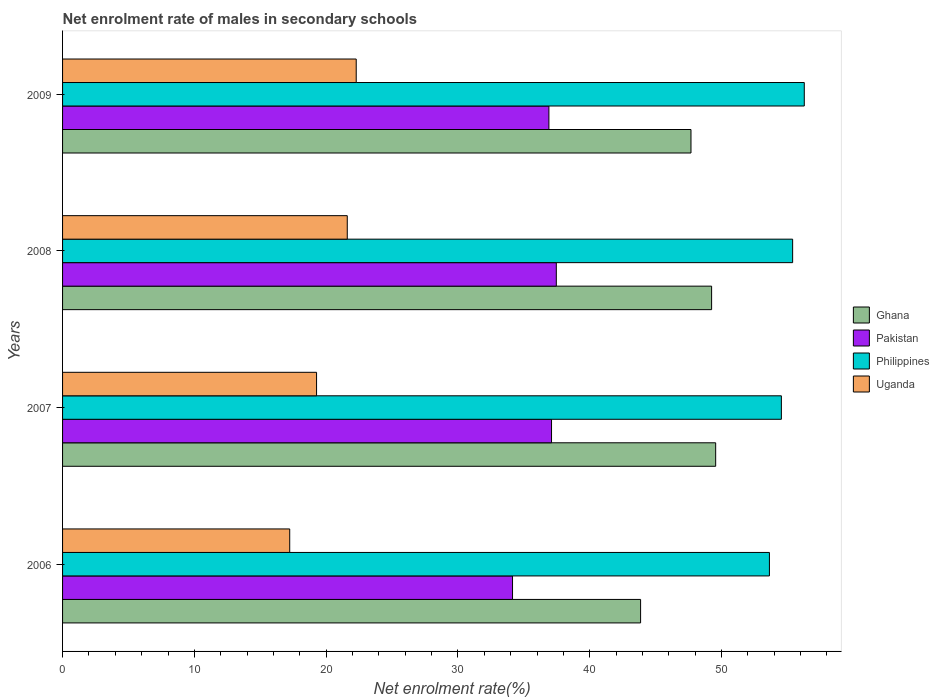How many different coloured bars are there?
Offer a very short reply. 4. Are the number of bars per tick equal to the number of legend labels?
Offer a terse response. Yes. In how many cases, is the number of bars for a given year not equal to the number of legend labels?
Ensure brevity in your answer.  0. What is the net enrolment rate of males in secondary schools in Ghana in 2006?
Your answer should be very brief. 43.86. Across all years, what is the maximum net enrolment rate of males in secondary schools in Philippines?
Your answer should be compact. 56.28. Across all years, what is the minimum net enrolment rate of males in secondary schools in Philippines?
Keep it short and to the point. 53.64. In which year was the net enrolment rate of males in secondary schools in Philippines maximum?
Keep it short and to the point. 2009. What is the total net enrolment rate of males in secondary schools in Ghana in the graph?
Your response must be concise. 190.35. What is the difference between the net enrolment rate of males in secondary schools in Philippines in 2008 and that in 2009?
Your response must be concise. -0.88. What is the difference between the net enrolment rate of males in secondary schools in Philippines in 2009 and the net enrolment rate of males in secondary schools in Ghana in 2008?
Offer a very short reply. 7.03. What is the average net enrolment rate of males in secondary schools in Ghana per year?
Your answer should be compact. 47.59. In the year 2008, what is the difference between the net enrolment rate of males in secondary schools in Ghana and net enrolment rate of males in secondary schools in Uganda?
Your response must be concise. 27.65. In how many years, is the net enrolment rate of males in secondary schools in Uganda greater than 38 %?
Provide a succinct answer. 0. What is the ratio of the net enrolment rate of males in secondary schools in Uganda in 2007 to that in 2009?
Offer a very short reply. 0.86. Is the difference between the net enrolment rate of males in secondary schools in Ghana in 2008 and 2009 greater than the difference between the net enrolment rate of males in secondary schools in Uganda in 2008 and 2009?
Keep it short and to the point. Yes. What is the difference between the highest and the second highest net enrolment rate of males in secondary schools in Uganda?
Provide a short and direct response. 0.68. What is the difference between the highest and the lowest net enrolment rate of males in secondary schools in Ghana?
Give a very brief answer. 5.7. Is it the case that in every year, the sum of the net enrolment rate of males in secondary schools in Ghana and net enrolment rate of males in secondary schools in Uganda is greater than the sum of net enrolment rate of males in secondary schools in Philippines and net enrolment rate of males in secondary schools in Pakistan?
Keep it short and to the point. Yes. What does the 1st bar from the top in 2009 represents?
Your answer should be compact. Uganda. Is it the case that in every year, the sum of the net enrolment rate of males in secondary schools in Pakistan and net enrolment rate of males in secondary schools in Philippines is greater than the net enrolment rate of males in secondary schools in Ghana?
Give a very brief answer. Yes. How many bars are there?
Ensure brevity in your answer.  16. Are all the bars in the graph horizontal?
Keep it short and to the point. Yes. How many years are there in the graph?
Keep it short and to the point. 4. Are the values on the major ticks of X-axis written in scientific E-notation?
Your answer should be very brief. No. Does the graph contain grids?
Make the answer very short. No. Where does the legend appear in the graph?
Offer a terse response. Center right. How are the legend labels stacked?
Offer a very short reply. Vertical. What is the title of the graph?
Give a very brief answer. Net enrolment rate of males in secondary schools. Does "Ecuador" appear as one of the legend labels in the graph?
Keep it short and to the point. No. What is the label or title of the X-axis?
Offer a terse response. Net enrolment rate(%). What is the label or title of the Y-axis?
Offer a very short reply. Years. What is the Net enrolment rate(%) in Ghana in 2006?
Make the answer very short. 43.86. What is the Net enrolment rate(%) in Pakistan in 2006?
Provide a succinct answer. 34.14. What is the Net enrolment rate(%) of Philippines in 2006?
Your answer should be compact. 53.64. What is the Net enrolment rate(%) in Uganda in 2006?
Make the answer very short. 17.24. What is the Net enrolment rate(%) of Ghana in 2007?
Give a very brief answer. 49.56. What is the Net enrolment rate(%) in Pakistan in 2007?
Your response must be concise. 37.1. What is the Net enrolment rate(%) in Philippines in 2007?
Your answer should be very brief. 54.54. What is the Net enrolment rate(%) in Uganda in 2007?
Your answer should be very brief. 19.27. What is the Net enrolment rate(%) in Ghana in 2008?
Make the answer very short. 49.25. What is the Net enrolment rate(%) in Pakistan in 2008?
Keep it short and to the point. 37.47. What is the Net enrolment rate(%) in Philippines in 2008?
Your answer should be compact. 55.4. What is the Net enrolment rate(%) in Uganda in 2008?
Ensure brevity in your answer.  21.6. What is the Net enrolment rate(%) of Ghana in 2009?
Your answer should be very brief. 47.68. What is the Net enrolment rate(%) in Pakistan in 2009?
Give a very brief answer. 36.9. What is the Net enrolment rate(%) in Philippines in 2009?
Offer a very short reply. 56.28. What is the Net enrolment rate(%) of Uganda in 2009?
Ensure brevity in your answer.  22.28. Across all years, what is the maximum Net enrolment rate(%) of Ghana?
Provide a succinct answer. 49.56. Across all years, what is the maximum Net enrolment rate(%) in Pakistan?
Keep it short and to the point. 37.47. Across all years, what is the maximum Net enrolment rate(%) in Philippines?
Provide a short and direct response. 56.28. Across all years, what is the maximum Net enrolment rate(%) of Uganda?
Offer a very short reply. 22.28. Across all years, what is the minimum Net enrolment rate(%) in Ghana?
Keep it short and to the point. 43.86. Across all years, what is the minimum Net enrolment rate(%) in Pakistan?
Your answer should be compact. 34.14. Across all years, what is the minimum Net enrolment rate(%) in Philippines?
Your response must be concise. 53.64. Across all years, what is the minimum Net enrolment rate(%) of Uganda?
Your answer should be very brief. 17.24. What is the total Net enrolment rate(%) of Ghana in the graph?
Your response must be concise. 190.35. What is the total Net enrolment rate(%) of Pakistan in the graph?
Give a very brief answer. 145.62. What is the total Net enrolment rate(%) in Philippines in the graph?
Your answer should be compact. 219.86. What is the total Net enrolment rate(%) of Uganda in the graph?
Provide a succinct answer. 80.4. What is the difference between the Net enrolment rate(%) of Ghana in 2006 and that in 2007?
Offer a very short reply. -5.7. What is the difference between the Net enrolment rate(%) in Pakistan in 2006 and that in 2007?
Make the answer very short. -2.96. What is the difference between the Net enrolment rate(%) of Philippines in 2006 and that in 2007?
Offer a terse response. -0.91. What is the difference between the Net enrolment rate(%) of Uganda in 2006 and that in 2007?
Keep it short and to the point. -2.04. What is the difference between the Net enrolment rate(%) in Ghana in 2006 and that in 2008?
Your response must be concise. -5.39. What is the difference between the Net enrolment rate(%) in Pakistan in 2006 and that in 2008?
Keep it short and to the point. -3.32. What is the difference between the Net enrolment rate(%) in Philippines in 2006 and that in 2008?
Your response must be concise. -1.76. What is the difference between the Net enrolment rate(%) in Uganda in 2006 and that in 2008?
Give a very brief answer. -4.37. What is the difference between the Net enrolment rate(%) in Ghana in 2006 and that in 2009?
Offer a very short reply. -3.82. What is the difference between the Net enrolment rate(%) of Pakistan in 2006 and that in 2009?
Make the answer very short. -2.76. What is the difference between the Net enrolment rate(%) in Philippines in 2006 and that in 2009?
Offer a terse response. -2.64. What is the difference between the Net enrolment rate(%) in Uganda in 2006 and that in 2009?
Offer a terse response. -5.05. What is the difference between the Net enrolment rate(%) in Ghana in 2007 and that in 2008?
Offer a terse response. 0.31. What is the difference between the Net enrolment rate(%) of Pakistan in 2007 and that in 2008?
Offer a very short reply. -0.36. What is the difference between the Net enrolment rate(%) in Philippines in 2007 and that in 2008?
Ensure brevity in your answer.  -0.85. What is the difference between the Net enrolment rate(%) of Uganda in 2007 and that in 2008?
Provide a short and direct response. -2.33. What is the difference between the Net enrolment rate(%) of Ghana in 2007 and that in 2009?
Offer a terse response. 1.87. What is the difference between the Net enrolment rate(%) in Pakistan in 2007 and that in 2009?
Your answer should be compact. 0.2. What is the difference between the Net enrolment rate(%) of Philippines in 2007 and that in 2009?
Offer a very short reply. -1.74. What is the difference between the Net enrolment rate(%) in Uganda in 2007 and that in 2009?
Keep it short and to the point. -3.01. What is the difference between the Net enrolment rate(%) in Ghana in 2008 and that in 2009?
Your answer should be very brief. 1.57. What is the difference between the Net enrolment rate(%) in Pakistan in 2008 and that in 2009?
Ensure brevity in your answer.  0.56. What is the difference between the Net enrolment rate(%) in Philippines in 2008 and that in 2009?
Give a very brief answer. -0.88. What is the difference between the Net enrolment rate(%) in Uganda in 2008 and that in 2009?
Ensure brevity in your answer.  -0.68. What is the difference between the Net enrolment rate(%) of Ghana in 2006 and the Net enrolment rate(%) of Pakistan in 2007?
Keep it short and to the point. 6.76. What is the difference between the Net enrolment rate(%) in Ghana in 2006 and the Net enrolment rate(%) in Philippines in 2007?
Your answer should be very brief. -10.68. What is the difference between the Net enrolment rate(%) in Ghana in 2006 and the Net enrolment rate(%) in Uganda in 2007?
Provide a short and direct response. 24.59. What is the difference between the Net enrolment rate(%) of Pakistan in 2006 and the Net enrolment rate(%) of Philippines in 2007?
Offer a terse response. -20.4. What is the difference between the Net enrolment rate(%) in Pakistan in 2006 and the Net enrolment rate(%) in Uganda in 2007?
Provide a succinct answer. 14.87. What is the difference between the Net enrolment rate(%) in Philippines in 2006 and the Net enrolment rate(%) in Uganda in 2007?
Your answer should be compact. 34.36. What is the difference between the Net enrolment rate(%) of Ghana in 2006 and the Net enrolment rate(%) of Pakistan in 2008?
Offer a terse response. 6.4. What is the difference between the Net enrolment rate(%) of Ghana in 2006 and the Net enrolment rate(%) of Philippines in 2008?
Your answer should be very brief. -11.54. What is the difference between the Net enrolment rate(%) of Ghana in 2006 and the Net enrolment rate(%) of Uganda in 2008?
Provide a short and direct response. 22.26. What is the difference between the Net enrolment rate(%) in Pakistan in 2006 and the Net enrolment rate(%) in Philippines in 2008?
Your answer should be very brief. -21.25. What is the difference between the Net enrolment rate(%) in Pakistan in 2006 and the Net enrolment rate(%) in Uganda in 2008?
Offer a very short reply. 12.54. What is the difference between the Net enrolment rate(%) in Philippines in 2006 and the Net enrolment rate(%) in Uganda in 2008?
Ensure brevity in your answer.  32.03. What is the difference between the Net enrolment rate(%) of Ghana in 2006 and the Net enrolment rate(%) of Pakistan in 2009?
Offer a terse response. 6.96. What is the difference between the Net enrolment rate(%) in Ghana in 2006 and the Net enrolment rate(%) in Philippines in 2009?
Provide a succinct answer. -12.42. What is the difference between the Net enrolment rate(%) in Ghana in 2006 and the Net enrolment rate(%) in Uganda in 2009?
Provide a succinct answer. 21.58. What is the difference between the Net enrolment rate(%) in Pakistan in 2006 and the Net enrolment rate(%) in Philippines in 2009?
Ensure brevity in your answer.  -22.14. What is the difference between the Net enrolment rate(%) of Pakistan in 2006 and the Net enrolment rate(%) of Uganda in 2009?
Provide a succinct answer. 11.86. What is the difference between the Net enrolment rate(%) in Philippines in 2006 and the Net enrolment rate(%) in Uganda in 2009?
Make the answer very short. 31.35. What is the difference between the Net enrolment rate(%) in Ghana in 2007 and the Net enrolment rate(%) in Pakistan in 2008?
Keep it short and to the point. 12.09. What is the difference between the Net enrolment rate(%) in Ghana in 2007 and the Net enrolment rate(%) in Philippines in 2008?
Make the answer very short. -5.84. What is the difference between the Net enrolment rate(%) in Ghana in 2007 and the Net enrolment rate(%) in Uganda in 2008?
Make the answer very short. 27.95. What is the difference between the Net enrolment rate(%) in Pakistan in 2007 and the Net enrolment rate(%) in Philippines in 2008?
Your answer should be very brief. -18.3. What is the difference between the Net enrolment rate(%) in Pakistan in 2007 and the Net enrolment rate(%) in Uganda in 2008?
Your answer should be compact. 15.5. What is the difference between the Net enrolment rate(%) of Philippines in 2007 and the Net enrolment rate(%) of Uganda in 2008?
Your response must be concise. 32.94. What is the difference between the Net enrolment rate(%) in Ghana in 2007 and the Net enrolment rate(%) in Pakistan in 2009?
Your answer should be very brief. 12.65. What is the difference between the Net enrolment rate(%) in Ghana in 2007 and the Net enrolment rate(%) in Philippines in 2009?
Your response must be concise. -6.72. What is the difference between the Net enrolment rate(%) in Ghana in 2007 and the Net enrolment rate(%) in Uganda in 2009?
Offer a terse response. 27.27. What is the difference between the Net enrolment rate(%) in Pakistan in 2007 and the Net enrolment rate(%) in Philippines in 2009?
Give a very brief answer. -19.18. What is the difference between the Net enrolment rate(%) in Pakistan in 2007 and the Net enrolment rate(%) in Uganda in 2009?
Make the answer very short. 14.82. What is the difference between the Net enrolment rate(%) in Philippines in 2007 and the Net enrolment rate(%) in Uganda in 2009?
Ensure brevity in your answer.  32.26. What is the difference between the Net enrolment rate(%) in Ghana in 2008 and the Net enrolment rate(%) in Pakistan in 2009?
Offer a very short reply. 12.35. What is the difference between the Net enrolment rate(%) in Ghana in 2008 and the Net enrolment rate(%) in Philippines in 2009?
Offer a very short reply. -7.03. What is the difference between the Net enrolment rate(%) in Ghana in 2008 and the Net enrolment rate(%) in Uganda in 2009?
Make the answer very short. 26.97. What is the difference between the Net enrolment rate(%) in Pakistan in 2008 and the Net enrolment rate(%) in Philippines in 2009?
Provide a short and direct response. -18.82. What is the difference between the Net enrolment rate(%) of Pakistan in 2008 and the Net enrolment rate(%) of Uganda in 2009?
Offer a terse response. 15.18. What is the difference between the Net enrolment rate(%) of Philippines in 2008 and the Net enrolment rate(%) of Uganda in 2009?
Your answer should be very brief. 33.12. What is the average Net enrolment rate(%) in Ghana per year?
Provide a short and direct response. 47.59. What is the average Net enrolment rate(%) in Pakistan per year?
Provide a succinct answer. 36.4. What is the average Net enrolment rate(%) of Philippines per year?
Provide a succinct answer. 54.97. What is the average Net enrolment rate(%) in Uganda per year?
Make the answer very short. 20.1. In the year 2006, what is the difference between the Net enrolment rate(%) in Ghana and Net enrolment rate(%) in Pakistan?
Offer a terse response. 9.72. In the year 2006, what is the difference between the Net enrolment rate(%) in Ghana and Net enrolment rate(%) in Philippines?
Provide a succinct answer. -9.78. In the year 2006, what is the difference between the Net enrolment rate(%) of Ghana and Net enrolment rate(%) of Uganda?
Ensure brevity in your answer.  26.62. In the year 2006, what is the difference between the Net enrolment rate(%) in Pakistan and Net enrolment rate(%) in Philippines?
Provide a succinct answer. -19.49. In the year 2006, what is the difference between the Net enrolment rate(%) of Pakistan and Net enrolment rate(%) of Uganda?
Provide a succinct answer. 16.91. In the year 2006, what is the difference between the Net enrolment rate(%) of Philippines and Net enrolment rate(%) of Uganda?
Your answer should be very brief. 36.4. In the year 2007, what is the difference between the Net enrolment rate(%) of Ghana and Net enrolment rate(%) of Pakistan?
Your answer should be very brief. 12.46. In the year 2007, what is the difference between the Net enrolment rate(%) in Ghana and Net enrolment rate(%) in Philippines?
Your response must be concise. -4.99. In the year 2007, what is the difference between the Net enrolment rate(%) in Ghana and Net enrolment rate(%) in Uganda?
Make the answer very short. 30.28. In the year 2007, what is the difference between the Net enrolment rate(%) in Pakistan and Net enrolment rate(%) in Philippines?
Give a very brief answer. -17.44. In the year 2007, what is the difference between the Net enrolment rate(%) of Pakistan and Net enrolment rate(%) of Uganda?
Give a very brief answer. 17.83. In the year 2007, what is the difference between the Net enrolment rate(%) in Philippines and Net enrolment rate(%) in Uganda?
Your response must be concise. 35.27. In the year 2008, what is the difference between the Net enrolment rate(%) in Ghana and Net enrolment rate(%) in Pakistan?
Your response must be concise. 11.78. In the year 2008, what is the difference between the Net enrolment rate(%) in Ghana and Net enrolment rate(%) in Philippines?
Provide a short and direct response. -6.15. In the year 2008, what is the difference between the Net enrolment rate(%) of Ghana and Net enrolment rate(%) of Uganda?
Offer a terse response. 27.65. In the year 2008, what is the difference between the Net enrolment rate(%) in Pakistan and Net enrolment rate(%) in Philippines?
Provide a succinct answer. -17.93. In the year 2008, what is the difference between the Net enrolment rate(%) in Pakistan and Net enrolment rate(%) in Uganda?
Offer a very short reply. 15.86. In the year 2008, what is the difference between the Net enrolment rate(%) in Philippines and Net enrolment rate(%) in Uganda?
Make the answer very short. 33.8. In the year 2009, what is the difference between the Net enrolment rate(%) in Ghana and Net enrolment rate(%) in Pakistan?
Give a very brief answer. 10.78. In the year 2009, what is the difference between the Net enrolment rate(%) in Ghana and Net enrolment rate(%) in Philippines?
Give a very brief answer. -8.6. In the year 2009, what is the difference between the Net enrolment rate(%) of Ghana and Net enrolment rate(%) of Uganda?
Your response must be concise. 25.4. In the year 2009, what is the difference between the Net enrolment rate(%) in Pakistan and Net enrolment rate(%) in Philippines?
Provide a succinct answer. -19.38. In the year 2009, what is the difference between the Net enrolment rate(%) of Pakistan and Net enrolment rate(%) of Uganda?
Offer a very short reply. 14.62. In the year 2009, what is the difference between the Net enrolment rate(%) of Philippines and Net enrolment rate(%) of Uganda?
Your response must be concise. 34. What is the ratio of the Net enrolment rate(%) of Ghana in 2006 to that in 2007?
Keep it short and to the point. 0.89. What is the ratio of the Net enrolment rate(%) in Pakistan in 2006 to that in 2007?
Offer a terse response. 0.92. What is the ratio of the Net enrolment rate(%) of Philippines in 2006 to that in 2007?
Your answer should be very brief. 0.98. What is the ratio of the Net enrolment rate(%) of Uganda in 2006 to that in 2007?
Provide a succinct answer. 0.89. What is the ratio of the Net enrolment rate(%) in Ghana in 2006 to that in 2008?
Make the answer very short. 0.89. What is the ratio of the Net enrolment rate(%) of Pakistan in 2006 to that in 2008?
Offer a terse response. 0.91. What is the ratio of the Net enrolment rate(%) in Philippines in 2006 to that in 2008?
Offer a very short reply. 0.97. What is the ratio of the Net enrolment rate(%) of Uganda in 2006 to that in 2008?
Your answer should be very brief. 0.8. What is the ratio of the Net enrolment rate(%) of Ghana in 2006 to that in 2009?
Give a very brief answer. 0.92. What is the ratio of the Net enrolment rate(%) in Pakistan in 2006 to that in 2009?
Provide a succinct answer. 0.93. What is the ratio of the Net enrolment rate(%) in Philippines in 2006 to that in 2009?
Your response must be concise. 0.95. What is the ratio of the Net enrolment rate(%) of Uganda in 2006 to that in 2009?
Offer a terse response. 0.77. What is the ratio of the Net enrolment rate(%) of Ghana in 2007 to that in 2008?
Offer a terse response. 1.01. What is the ratio of the Net enrolment rate(%) of Pakistan in 2007 to that in 2008?
Offer a very short reply. 0.99. What is the ratio of the Net enrolment rate(%) in Philippines in 2007 to that in 2008?
Offer a very short reply. 0.98. What is the ratio of the Net enrolment rate(%) in Uganda in 2007 to that in 2008?
Offer a very short reply. 0.89. What is the ratio of the Net enrolment rate(%) of Ghana in 2007 to that in 2009?
Provide a short and direct response. 1.04. What is the ratio of the Net enrolment rate(%) in Pakistan in 2007 to that in 2009?
Give a very brief answer. 1.01. What is the ratio of the Net enrolment rate(%) of Philippines in 2007 to that in 2009?
Ensure brevity in your answer.  0.97. What is the ratio of the Net enrolment rate(%) of Uganda in 2007 to that in 2009?
Provide a short and direct response. 0.86. What is the ratio of the Net enrolment rate(%) of Ghana in 2008 to that in 2009?
Offer a terse response. 1.03. What is the ratio of the Net enrolment rate(%) of Pakistan in 2008 to that in 2009?
Ensure brevity in your answer.  1.02. What is the ratio of the Net enrolment rate(%) of Philippines in 2008 to that in 2009?
Provide a succinct answer. 0.98. What is the ratio of the Net enrolment rate(%) in Uganda in 2008 to that in 2009?
Keep it short and to the point. 0.97. What is the difference between the highest and the second highest Net enrolment rate(%) in Ghana?
Provide a short and direct response. 0.31. What is the difference between the highest and the second highest Net enrolment rate(%) in Pakistan?
Offer a very short reply. 0.36. What is the difference between the highest and the second highest Net enrolment rate(%) in Philippines?
Ensure brevity in your answer.  0.88. What is the difference between the highest and the second highest Net enrolment rate(%) in Uganda?
Provide a short and direct response. 0.68. What is the difference between the highest and the lowest Net enrolment rate(%) in Ghana?
Provide a succinct answer. 5.7. What is the difference between the highest and the lowest Net enrolment rate(%) in Pakistan?
Offer a very short reply. 3.32. What is the difference between the highest and the lowest Net enrolment rate(%) in Philippines?
Make the answer very short. 2.64. What is the difference between the highest and the lowest Net enrolment rate(%) in Uganda?
Your answer should be very brief. 5.05. 